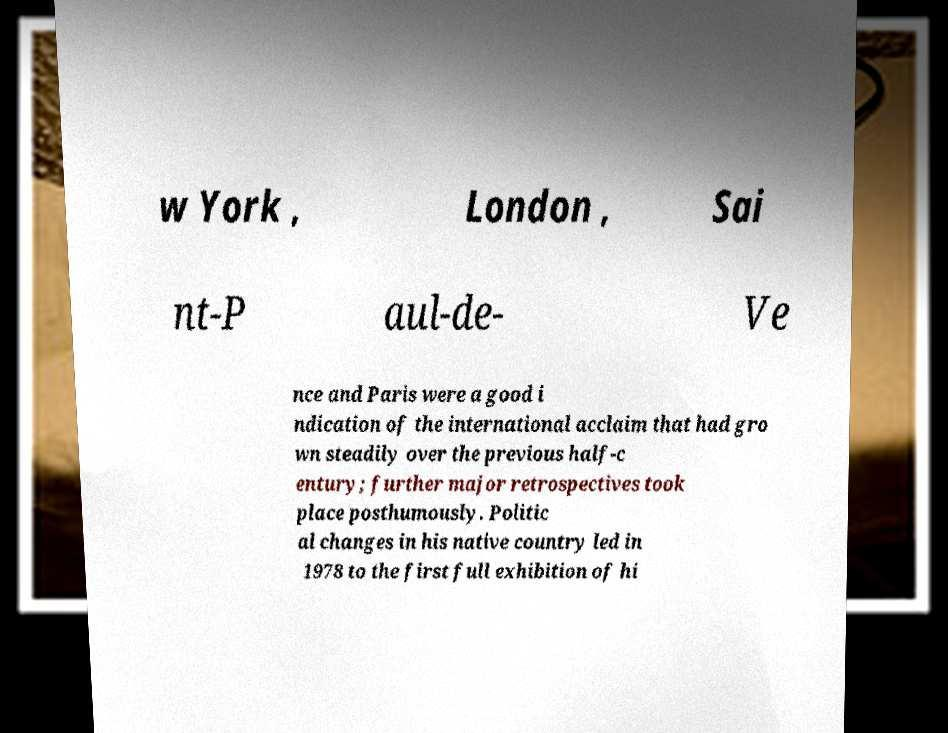I need the written content from this picture converted into text. Can you do that? w York , London , Sai nt-P aul-de- Ve nce and Paris were a good i ndication of the international acclaim that had gro wn steadily over the previous half-c entury; further major retrospectives took place posthumously. Politic al changes in his native country led in 1978 to the first full exhibition of hi 